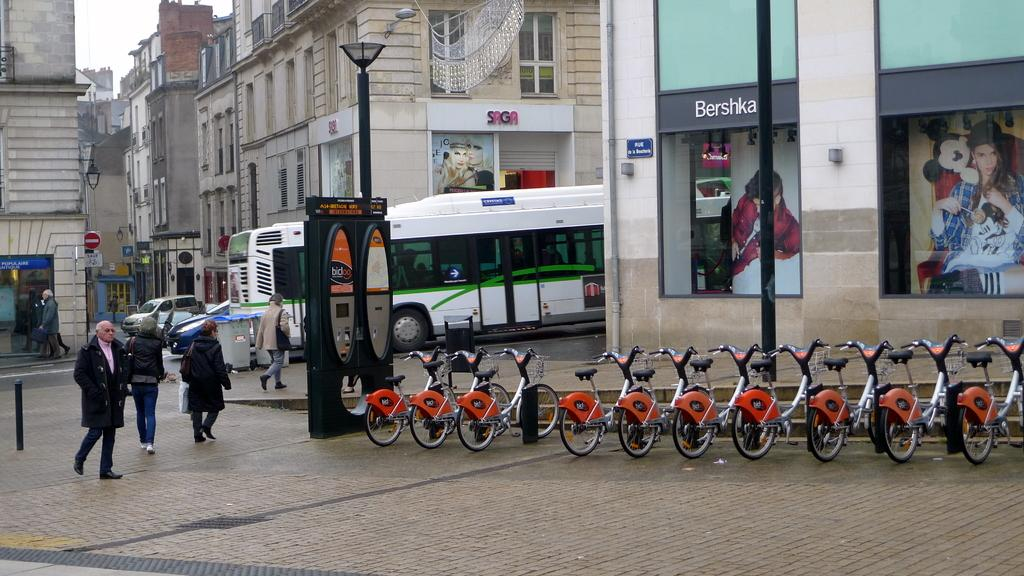<image>
Create a compact narrative representing the image presented. People walking towards a bus next to a building that says SAGA. 